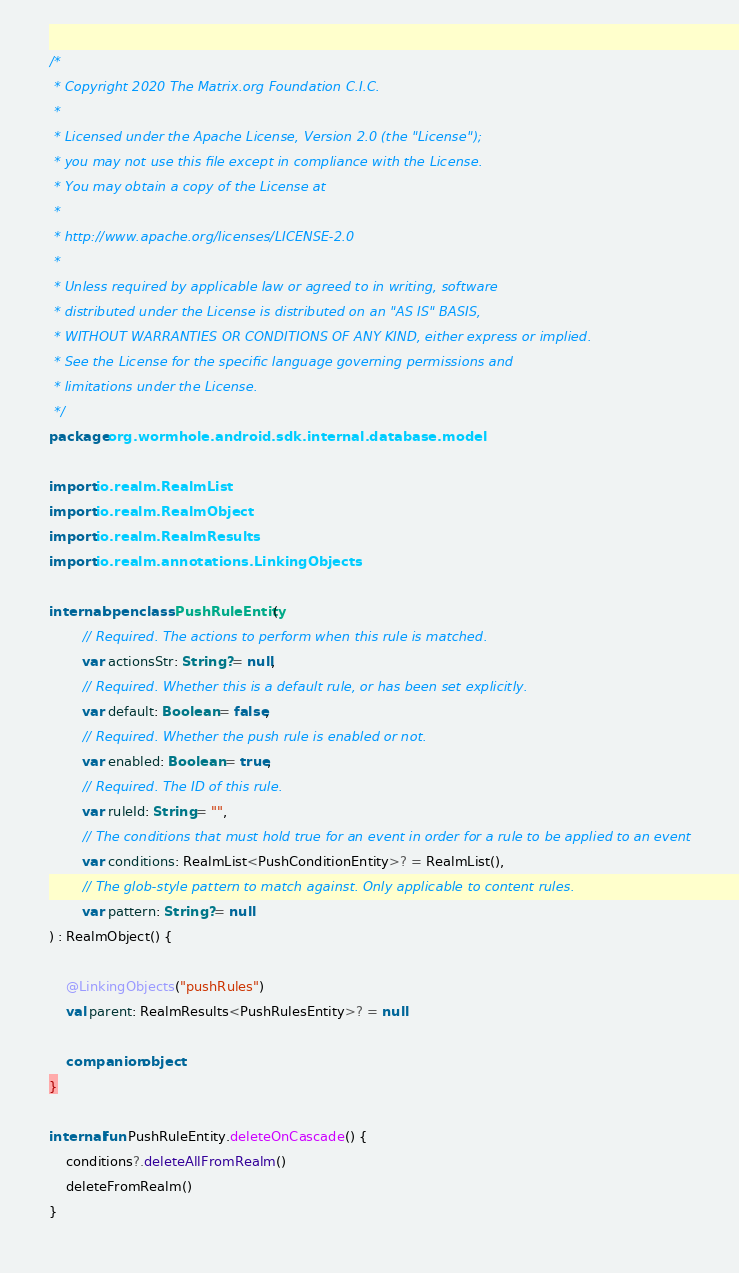<code> <loc_0><loc_0><loc_500><loc_500><_Kotlin_>/*
 * Copyright 2020 The Matrix.org Foundation C.I.C.
 *
 * Licensed under the Apache License, Version 2.0 (the "License");
 * you may not use this file except in compliance with the License.
 * You may obtain a copy of the License at
 *
 * http://www.apache.org/licenses/LICENSE-2.0
 *
 * Unless required by applicable law or agreed to in writing, software
 * distributed under the License is distributed on an "AS IS" BASIS,
 * WITHOUT WARRANTIES OR CONDITIONS OF ANY KIND, either express or implied.
 * See the License for the specific language governing permissions and
 * limitations under the License.
 */
package org.wormhole.android.sdk.internal.database.model

import io.realm.RealmList
import io.realm.RealmObject
import io.realm.RealmResults
import io.realm.annotations.LinkingObjects

internal open class PushRuleEntity(
        // Required. The actions to perform when this rule is matched.
        var actionsStr: String? = null,
        // Required. Whether this is a default rule, or has been set explicitly.
        var default: Boolean = false,
        // Required. Whether the push rule is enabled or not.
        var enabled: Boolean = true,
        // Required. The ID of this rule.
        var ruleId: String = "",
        // The conditions that must hold true for an event in order for a rule to be applied to an event
        var conditions: RealmList<PushConditionEntity>? = RealmList(),
        // The glob-style pattern to match against. Only applicable to content rules.
        var pattern: String? = null
) : RealmObject() {

    @LinkingObjects("pushRules")
    val parent: RealmResults<PushRulesEntity>? = null

    companion object
}

internal fun PushRuleEntity.deleteOnCascade() {
    conditions?.deleteAllFromRealm()
    deleteFromRealm()
}
</code> 